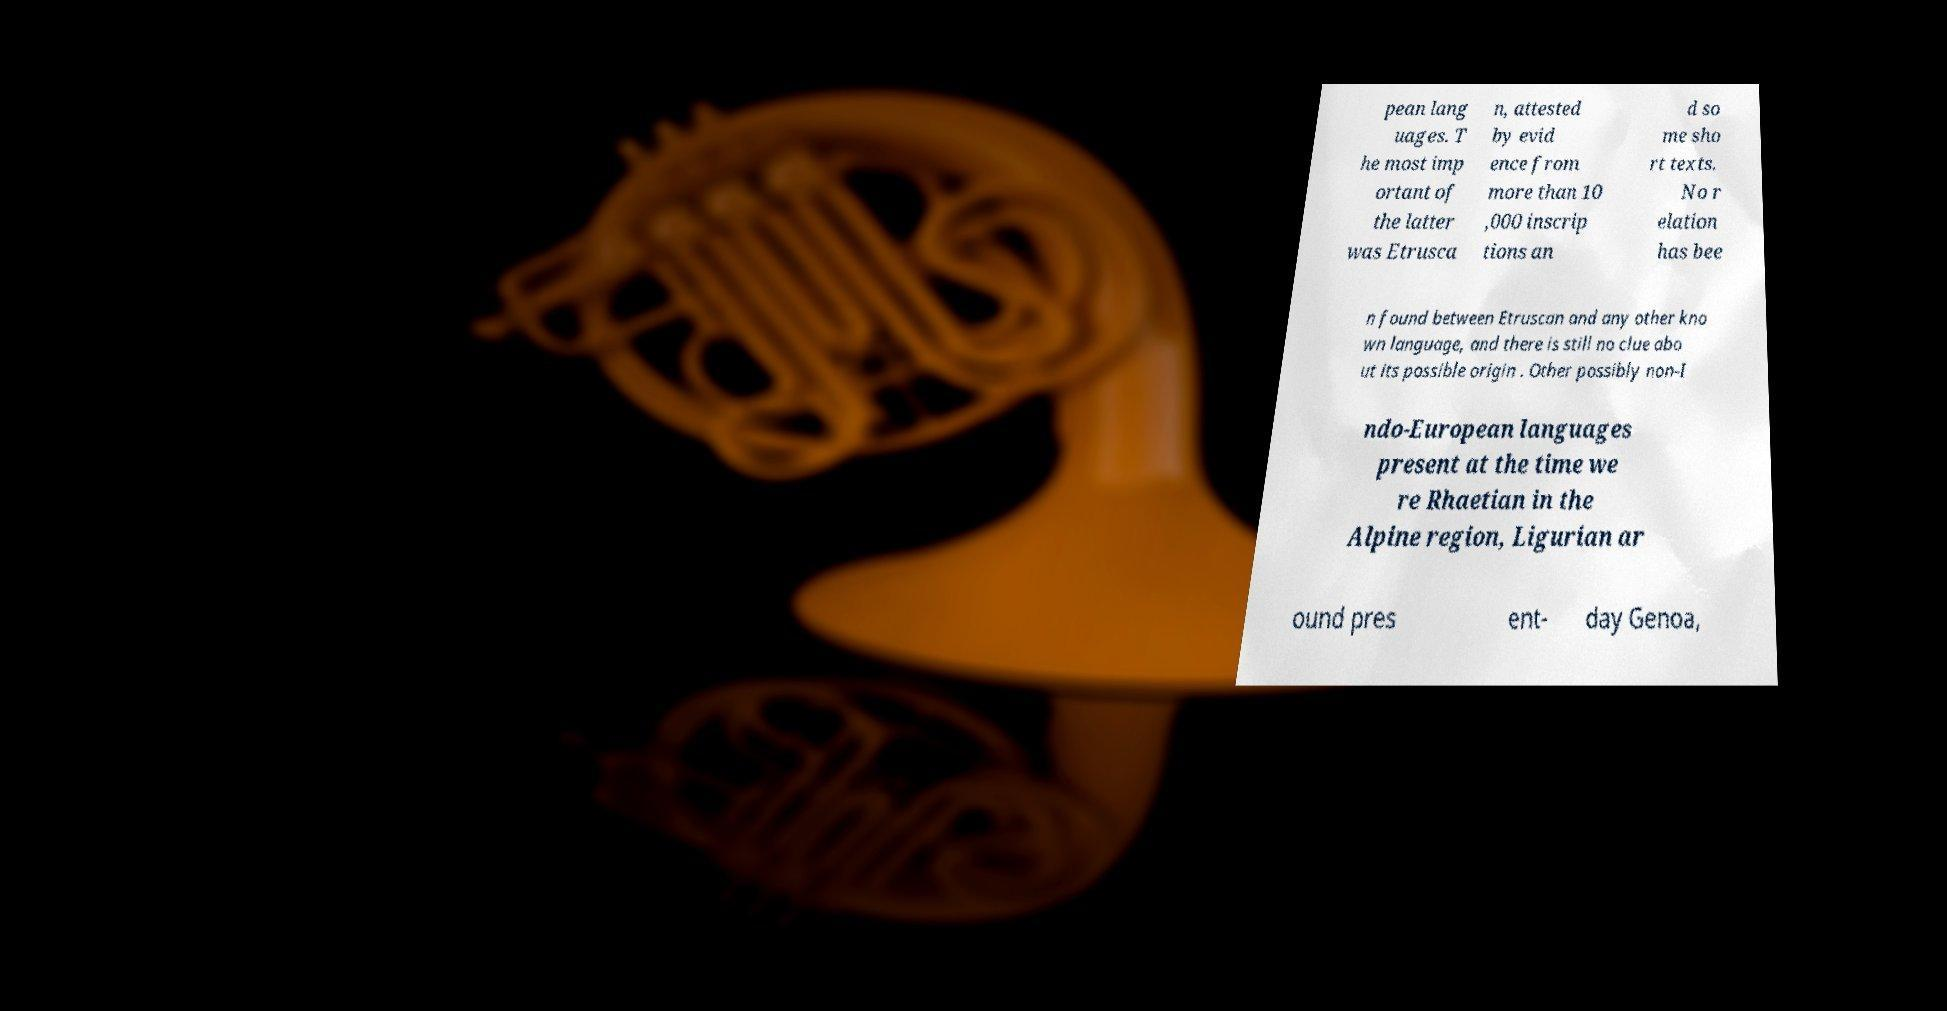There's text embedded in this image that I need extracted. Can you transcribe it verbatim? pean lang uages. T he most imp ortant of the latter was Etrusca n, attested by evid ence from more than 10 ,000 inscrip tions an d so me sho rt texts. No r elation has bee n found between Etruscan and any other kno wn language, and there is still no clue abo ut its possible origin . Other possibly non-I ndo-European languages present at the time we re Rhaetian in the Alpine region, Ligurian ar ound pres ent- day Genoa, 